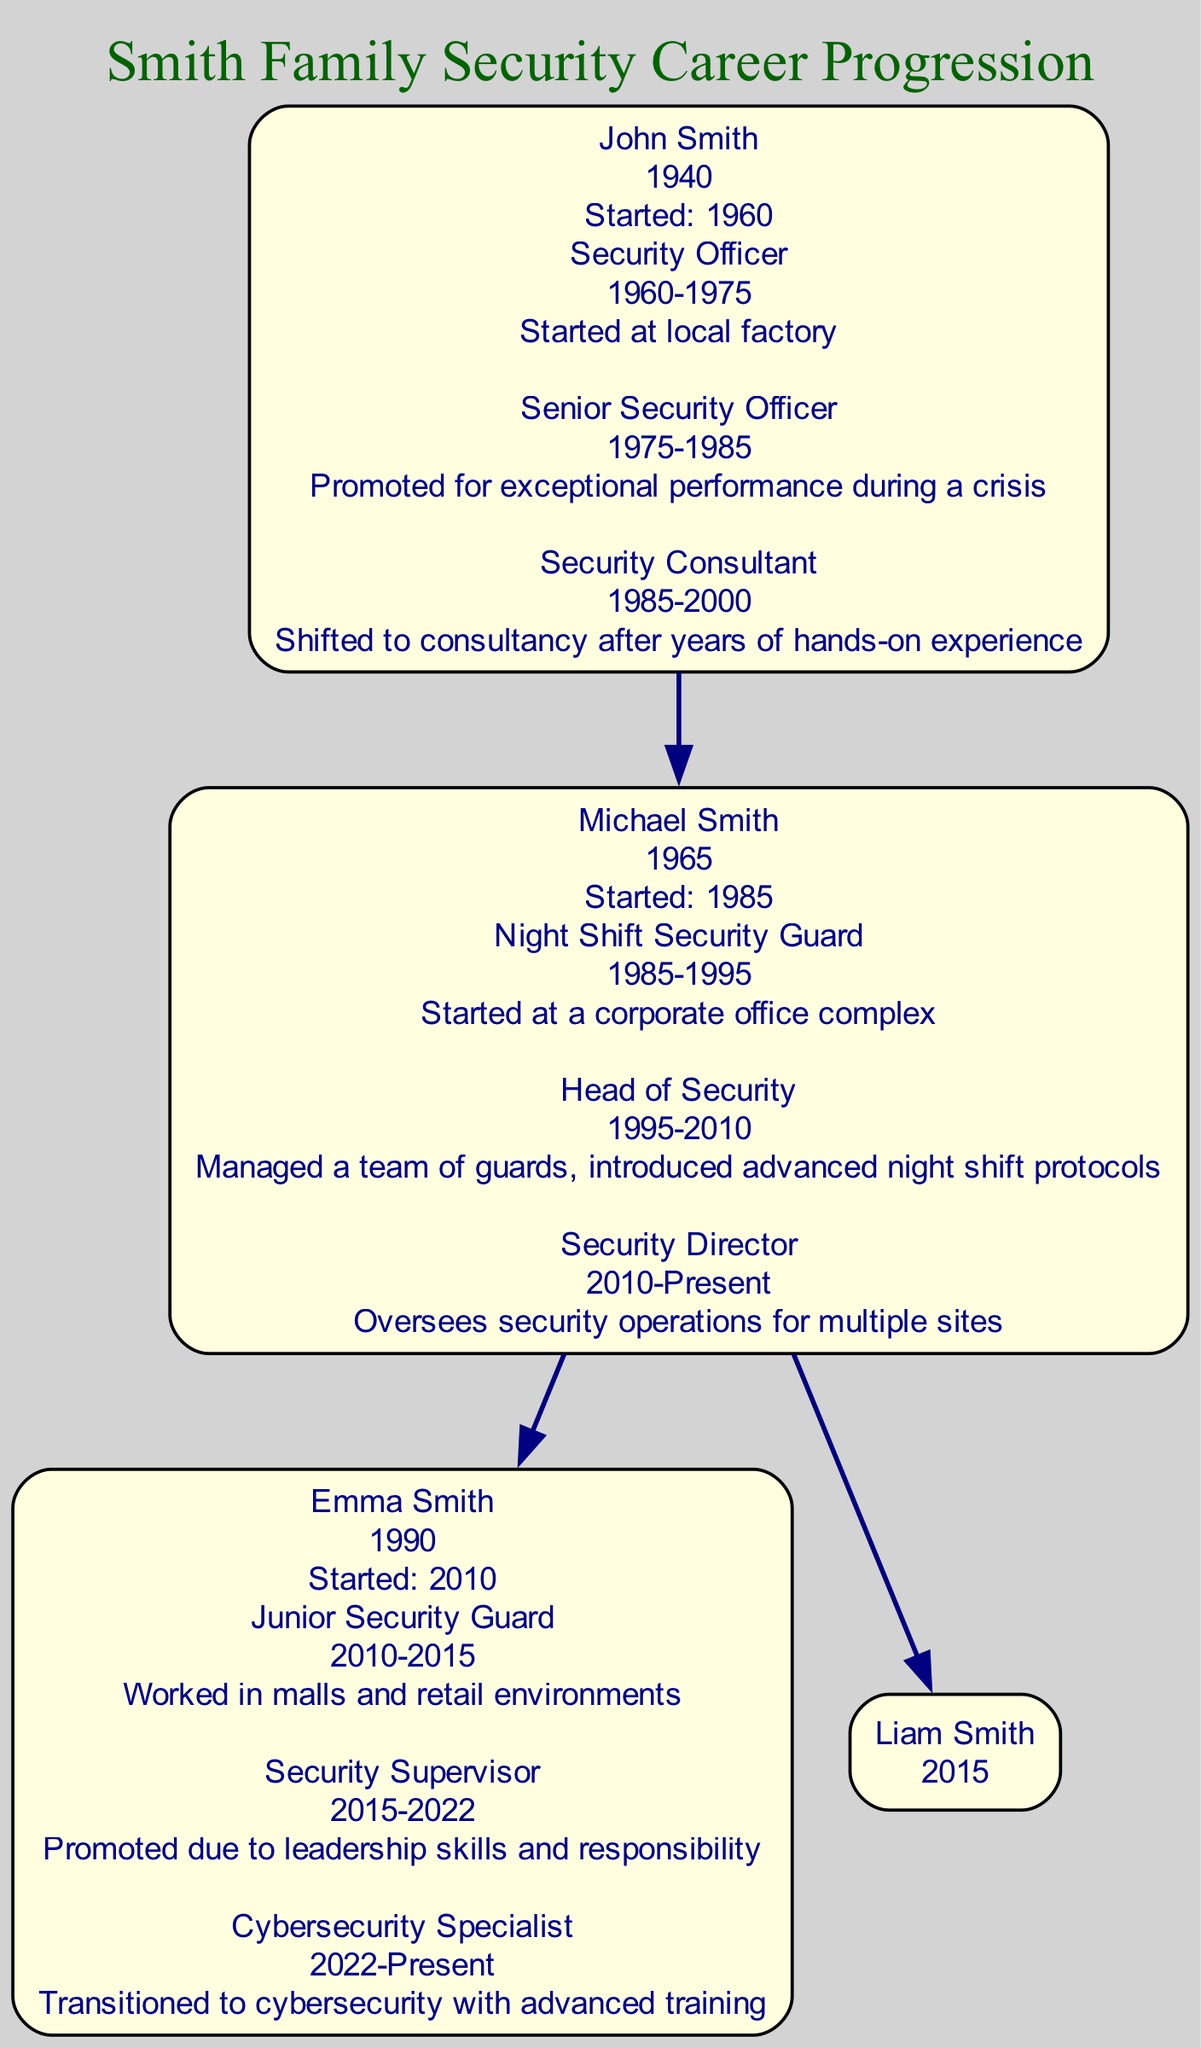What is the role of John Smith during the years 1975-1985? In the career progression section of John Smith, it lists "Senior Security Officer" under his roles, specifying the timeframe as 1975-1985 before he transitioned to Security Consultant.
Answer: Senior Security Officer Who succeeded Michael Smith as a security supervisor? Looking at Michael Smith's career progression, the next family member, Emma Smith, who was a Security Supervisor from 2015 to 2022, indicates that she succeeded him in a supervisory role as he held the Head of Security position until 2010.
Answer: Emma Smith How many different roles did John Smith have throughout his career? Examining the list of roles in John Smith's career progression, he has three distinct roles: Security Officer, Senior Security Officer, and Security Consultant, which makes the total count three.
Answer: 3 Which family member began their security career as a Junior Security Guard? In the career progression of Emma Smith, she initiated her career as a Junior Security Guard starting in 2010 for five years before moving to the next role, confirming she was the one who began in that position.
Answer: Emma Smith What notable security role does Michael Smith currently hold? In Michael Smith's career progression, the last noted role is "Security Director" with the timeframe specified as 2010-Present, indicating this is his current position.
Answer: Security Director Who is the youngest member of the Smith family? The data lists Liam Smith, born in 2015, as the youngest member of the Smith family, as John Smith was born in 1940, Michael Smith in 1965, and Emma Smith in 1990, making Liam the youngest by birth year.
Answer: Liam Smith How many edges connect the family members in this family tree? The edges represent the direct parental connections shown in the diagram, which connects John Smith to his son Michael Smith, and Michael Smith to his children Emma and Liam, resulting in a total of three edges.
Answer: 3 During what years did Emma Smith serve as a Security Supervisor? In the career progression of Emma Smith, it's specified that her tenure as a Security Supervisor lasted from 2015 until 2022, marking the years in which she held this role.
Answer: 2015-2022 What is the main area of expertise for Emma Smith at present? Emma Smith's current role is identified as a Cybersecurity Specialist as of 2022, indicating her shift in focus towards the realm of cybersecurity after her previous roles in security.
Answer: Cybersecurity Specialist 